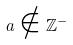Convert formula to latex. <formula><loc_0><loc_0><loc_500><loc_500>a \notin \mathbb { Z } ^ { - }</formula> 